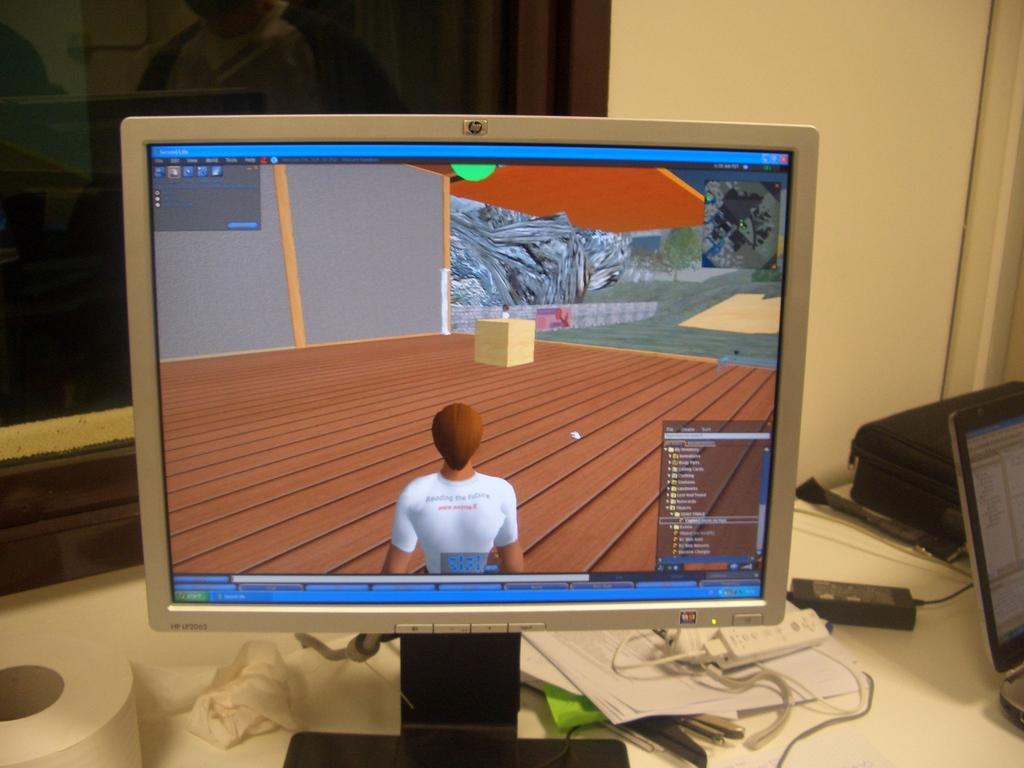What brand of pc monitor is this?
Give a very brief answer. Hp. 